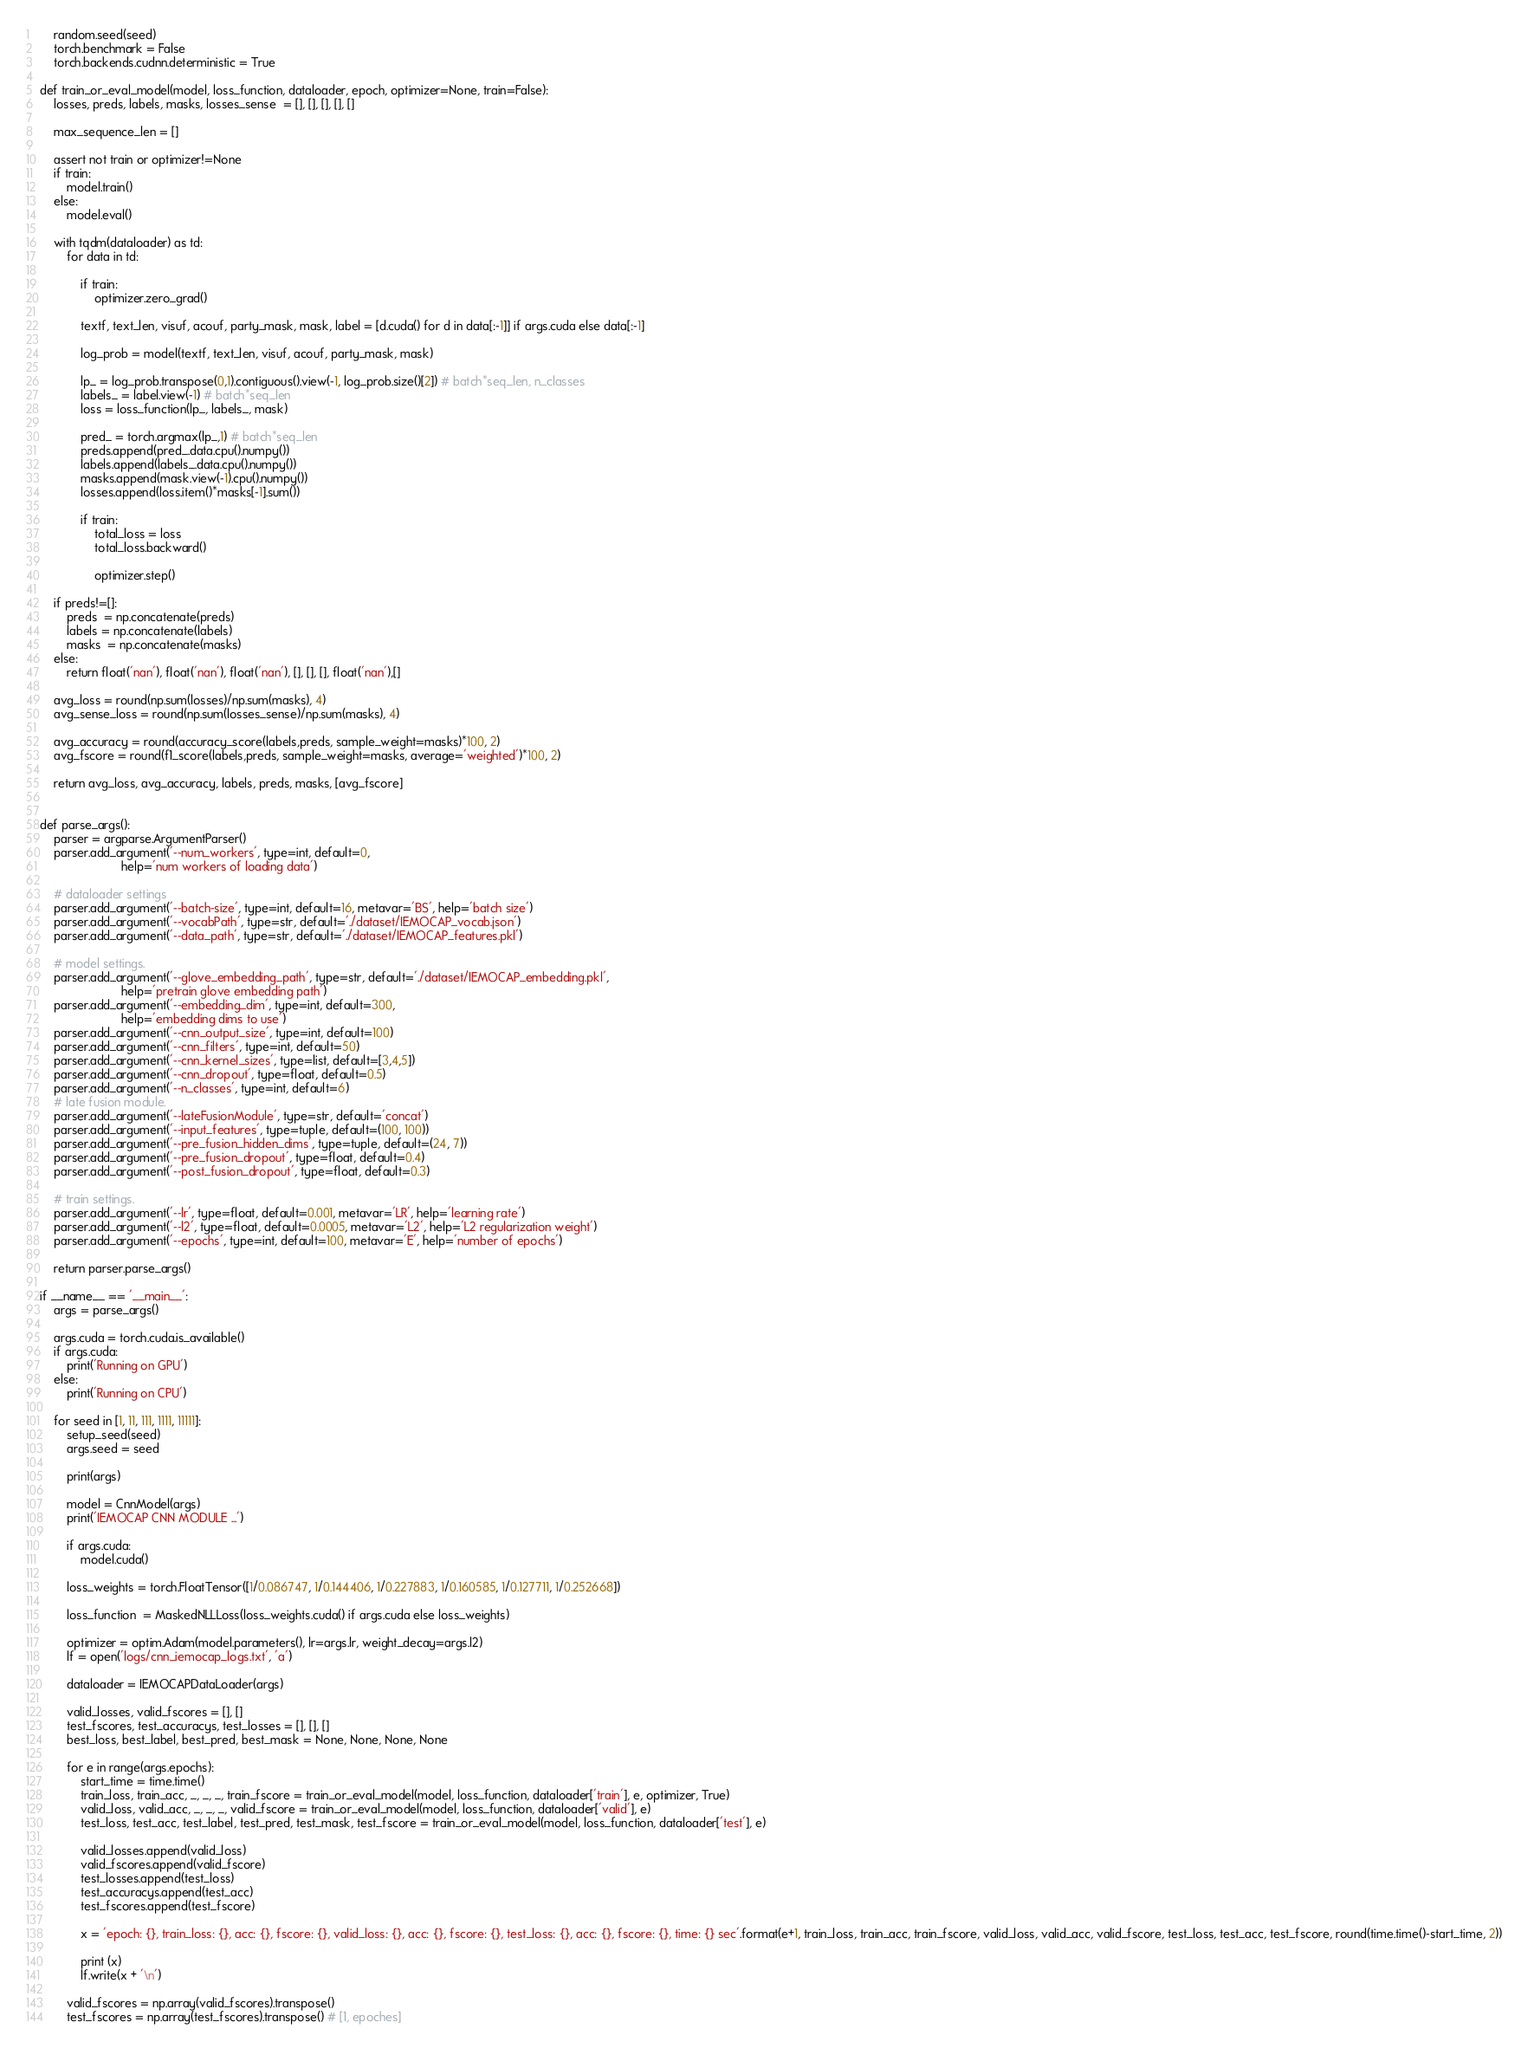Convert code to text. <code><loc_0><loc_0><loc_500><loc_500><_Python_>    random.seed(seed)
    torch.benchmark = False
    torch.backends.cudnn.deterministic = True

def train_or_eval_model(model, loss_function, dataloader, epoch, optimizer=None, train=False):
    losses, preds, labels, masks, losses_sense  = [], [], [], [], []
    
    max_sequence_len = []

    assert not train or optimizer!=None
    if train:
        model.train()
    else:
        model.eval()
    
    with tqdm(dataloader) as td:
        for data in td:

            if train:
                optimizer.zero_grad()
                
            textf, text_len, visuf, acouf, party_mask, mask, label = [d.cuda() for d in data[:-1]] if args.cuda else data[:-1]
            
            log_prob = model(textf, text_len, visuf, acouf, party_mask, mask)

            lp_ = log_prob.transpose(0,1).contiguous().view(-1, log_prob.size()[2]) # batch*seq_len, n_classes
            labels_ = label.view(-1) # batch*seq_len
            loss = loss_function(lp_, labels_, mask)

            pred_ = torch.argmax(lp_,1) # batch*seq_len
            preds.append(pred_.data.cpu().numpy())
            labels.append(labels_.data.cpu().numpy())
            masks.append(mask.view(-1).cpu().numpy())
            losses.append(loss.item()*masks[-1].sum())

            if train:
                total_loss = loss
                total_loss.backward()
                
                optimizer.step()

    if preds!=[]:
        preds  = np.concatenate(preds)
        labels = np.concatenate(labels)
        masks  = np.concatenate(masks)
    else:
        return float('nan'), float('nan'), float('nan'), [], [], [], float('nan'),[]

    avg_loss = round(np.sum(losses)/np.sum(masks), 4)
    avg_sense_loss = round(np.sum(losses_sense)/np.sum(masks), 4)

    avg_accuracy = round(accuracy_score(labels,preds, sample_weight=masks)*100, 2)
    avg_fscore = round(f1_score(labels,preds, sample_weight=masks, average='weighted')*100, 2)
    
    return avg_loss, avg_accuracy, labels, preds, masks, [avg_fscore]


def parse_args():
    parser = argparse.ArgumentParser()
    parser.add_argument('--num_workers', type=int, default=0,
                        help='num workers of loading data')
    
    # dataloader settings 
    parser.add_argument('--batch-size', type=int, default=16, metavar='BS', help='batch size')
    parser.add_argument('--vocabPath', type=str, default='./dataset/IEMOCAP_vocab.json')
    parser.add_argument('--data_path', type=str, default='./dataset/IEMOCAP_features.pkl')

    # model settings.
    parser.add_argument('--glove_embedding_path', type=str, default='./dataset/IEMOCAP_embedding.pkl',
                        help='pretrain glove embedding path')
    parser.add_argument('--embedding_dim', type=int, default=300,
                        help='embedding dims to use')
    parser.add_argument('--cnn_output_size', type=int, default=100)
    parser.add_argument('--cnn_filters', type=int, default=50)
    parser.add_argument('--cnn_kernel_sizes', type=list, default=[3,4,5])
    parser.add_argument('--cnn_dropout', type=float, default=0.5)
    parser.add_argument('--n_classes', type=int, default=6)
    # late fusion module.
    parser.add_argument('--lateFusionModule', type=str, default='concat')
    parser.add_argument('--input_features', type=tuple, default=(100, 100))
    parser.add_argument('--pre_fusion_hidden_dims', type=tuple, default=(24, 7))
    parser.add_argument('--pre_fusion_dropout', type=float, default=0.4)
    parser.add_argument('--post_fusion_dropout', type=float, default=0.3)

    # train settings.
    parser.add_argument('--lr', type=float, default=0.001, metavar='LR', help='learning rate')
    parser.add_argument('--l2', type=float, default=0.0005, metavar='L2', help='L2 regularization weight')
    parser.add_argument('--epochs', type=int, default=100, metavar='E', help='number of epochs')

    return parser.parse_args()

if __name__ == '__main__':
    args = parse_args()

    args.cuda = torch.cuda.is_available()
    if args.cuda:
        print('Running on GPU')
    else:
        print('Running on CPU')

    for seed in [1, 11, 111, 1111, 11111]:
        setup_seed(seed)
        args.seed = seed
        
        print(args)

        model = CnnModel(args)
        print('IEMOCAP CNN MODULE ...')

        if args.cuda:
            model.cuda()
        
        loss_weights = torch.FloatTensor([1/0.086747, 1/0.144406, 1/0.227883, 1/0.160585, 1/0.127711, 1/0.252668])
        
        loss_function  = MaskedNLLLoss(loss_weights.cuda() if args.cuda else loss_weights)
        
        optimizer = optim.Adam(model.parameters(), lr=args.lr, weight_decay=args.l2)
        lf = open('logs/cnn_iemocap_logs.txt', 'a')
        
        dataloader = IEMOCAPDataLoader(args)

        valid_losses, valid_fscores = [], []
        test_fscores, test_accuracys, test_losses = [], [], []
        best_loss, best_label, best_pred, best_mask = None, None, None, None

        for e in range(args.epochs):
            start_time = time.time()
            train_loss, train_acc, _, _, _, train_fscore = train_or_eval_model(model, loss_function, dataloader['train'], e, optimizer, True)
            valid_loss, valid_acc, _, _, _, valid_fscore = train_or_eval_model(model, loss_function, dataloader['valid'], e)
            test_loss, test_acc, test_label, test_pred, test_mask, test_fscore = train_or_eval_model(model, loss_function, dataloader['test'], e)
                
            valid_losses.append(valid_loss)
            valid_fscores.append(valid_fscore)
            test_losses.append(test_loss)
            test_accuracys.append(test_acc)
            test_fscores.append(test_fscore)
                
            x = 'epoch: {}, train_loss: {}, acc: {}, fscore: {}, valid_loss: {}, acc: {}, fscore: {}, test_loss: {}, acc: {}, fscore: {}, time: {} sec'.format(e+1, train_loss, train_acc, train_fscore, valid_loss, valid_acc, valid_fscore, test_loss, test_acc, test_fscore, round(time.time()-start_time, 2))
            
            print (x)
            lf.write(x + '\n')

        valid_fscores = np.array(valid_fscores).transpose()
        test_fscores = np.array(test_fscores).transpose() # [1, epoches]</code> 